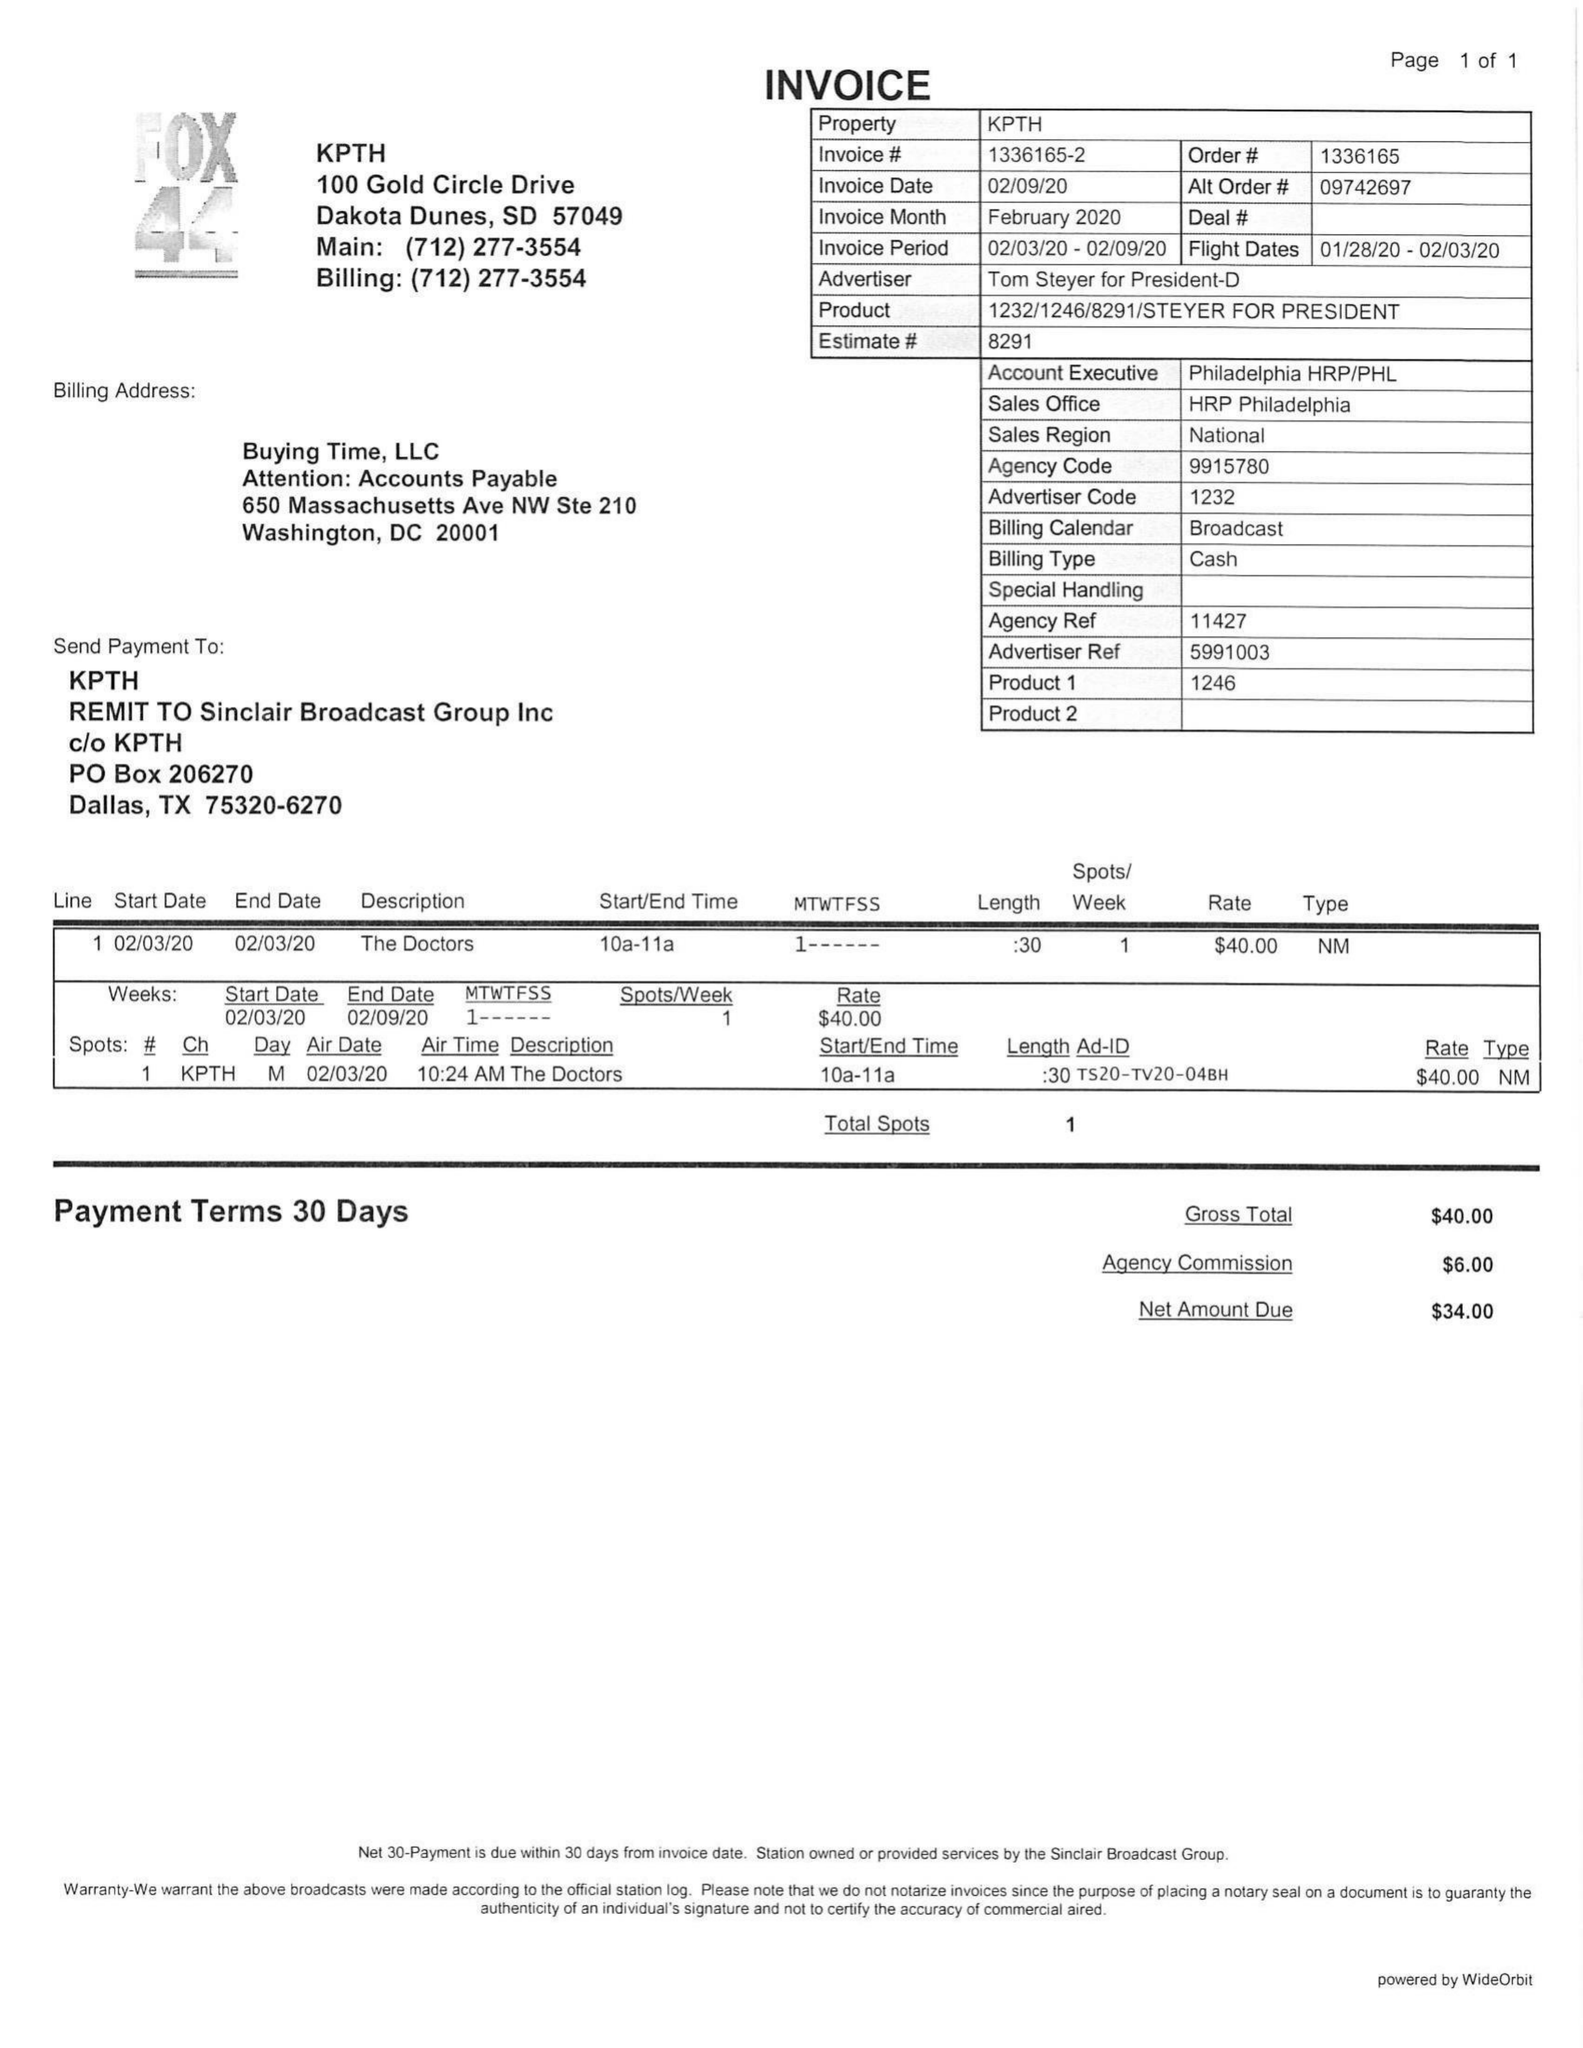What is the value for the advertiser?
Answer the question using a single word or phrase. TOM STEYER FOR PRESIDENT 